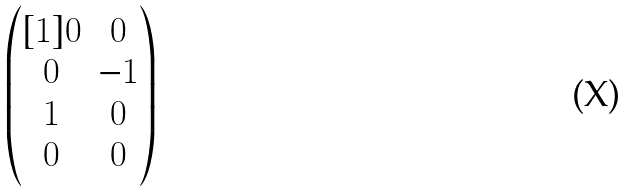<formula> <loc_0><loc_0><loc_500><loc_500>\begin{pmatrix} [ 1 ] 0 & 0 \\ 0 & - 1 \\ 1 & 0 \\ 0 & 0 \\ \end{pmatrix}</formula> 